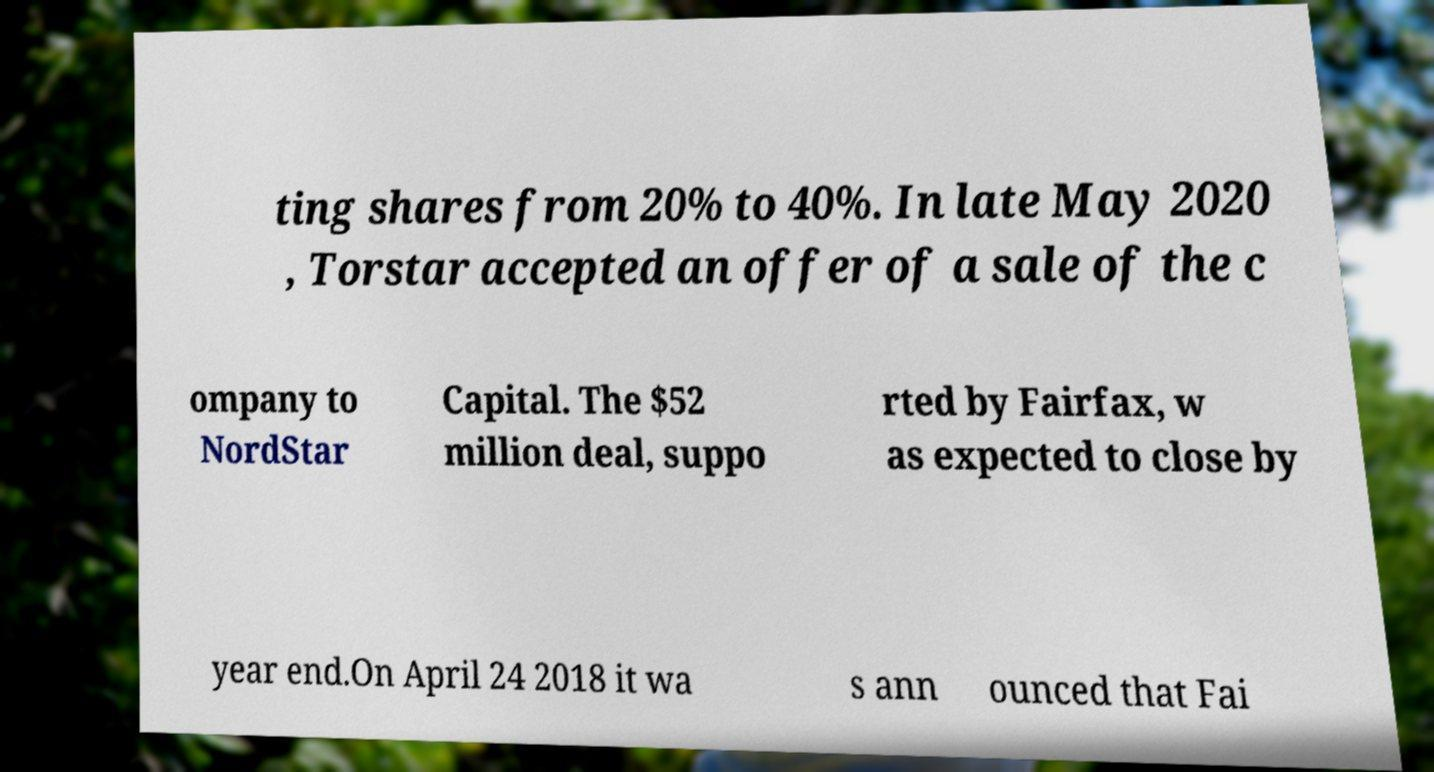Could you assist in decoding the text presented in this image and type it out clearly? ting shares from 20% to 40%. In late May 2020 , Torstar accepted an offer of a sale of the c ompany to NordStar Capital. The $52 million deal, suppo rted by Fairfax, w as expected to close by year end.On April 24 2018 it wa s ann ounced that Fai 